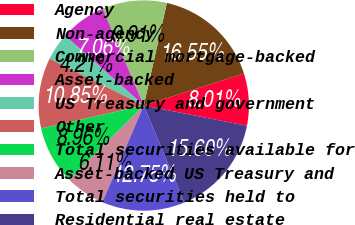Convert chart to OTSL. <chart><loc_0><loc_0><loc_500><loc_500><pie_chart><fcel>Agency<fcel>Non-agency<fcel>Commercial mortgage-backed<fcel>Asset-backed<fcel>US Treasury and government<fcel>Other<fcel>Total securities available for<fcel>Asset-backed US Treasury and<fcel>Total securities held to<fcel>Residential real estate<nl><fcel>8.01%<fcel>16.55%<fcel>9.91%<fcel>7.06%<fcel>4.21%<fcel>10.85%<fcel>8.96%<fcel>6.11%<fcel>12.75%<fcel>15.6%<nl></chart> 